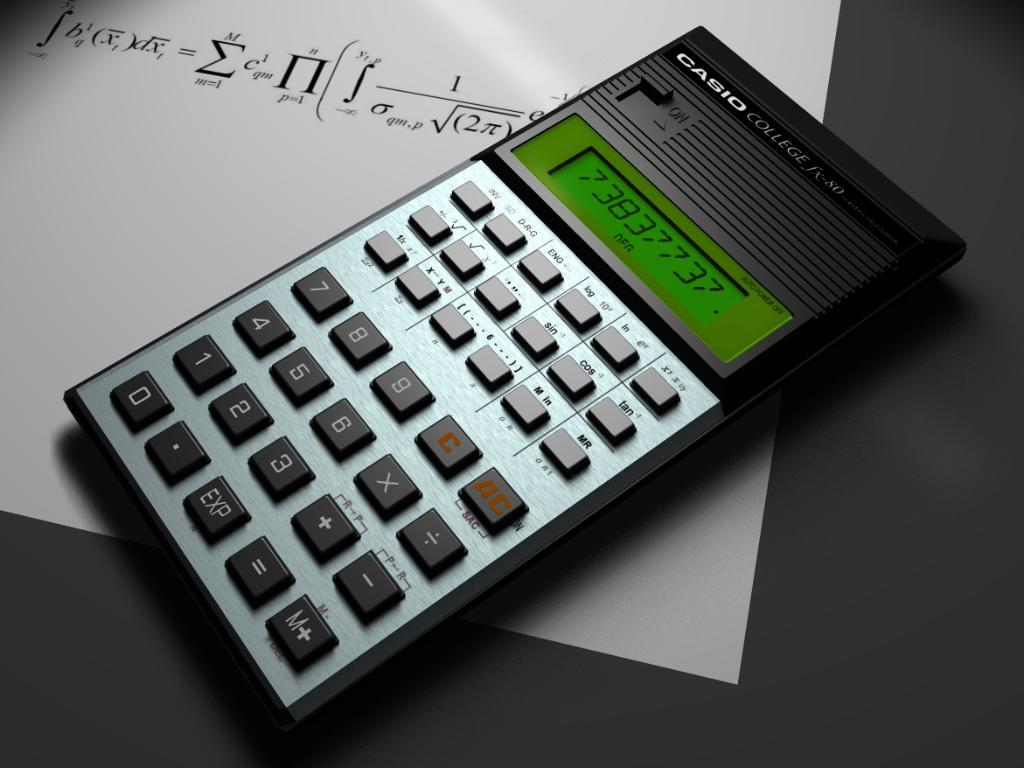<image>
Give a short and clear explanation of the subsequent image. A Casio calculator on top of a piece of paper with equations on it. 